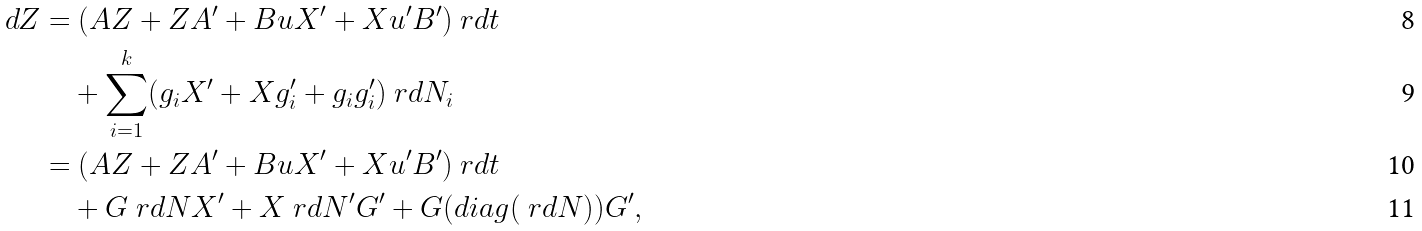Convert formula to latex. <formula><loc_0><loc_0><loc_500><loc_500>d Z & = ( A Z + Z A ^ { \prime } + B u X ^ { \prime } + X u ^ { \prime } B ^ { \prime } ) \ r d t \\ & \quad + \sum _ { i = 1 } ^ { k } ( g _ { i } X ^ { \prime } + X g _ { i } ^ { \prime } + g _ { i } g _ { i } ^ { \prime } ) \ r d N _ { i } \\ & = ( A Z + Z A ^ { \prime } + B u X ^ { \prime } + X u ^ { \prime } B ^ { \prime } ) \ r d t \\ & \quad + G \ r d N X ^ { \prime } + X \ r d N ^ { \prime } G ^ { \prime } + G ( d i a g ( \ r d N ) ) G ^ { \prime } ,</formula> 